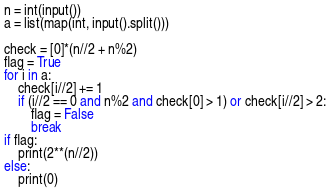Convert code to text. <code><loc_0><loc_0><loc_500><loc_500><_Python_>n = int(input())
a = list(map(int, input().split()))

check = [0]*(n//2 + n%2)
flag = True
for i in a:
    check[i//2] += 1
    if (i//2 == 0 and n%2 and check[0] > 1) or check[i//2] > 2:
        flag = False
        break
if flag:
    print(2**(n//2))
else:
    print(0)</code> 